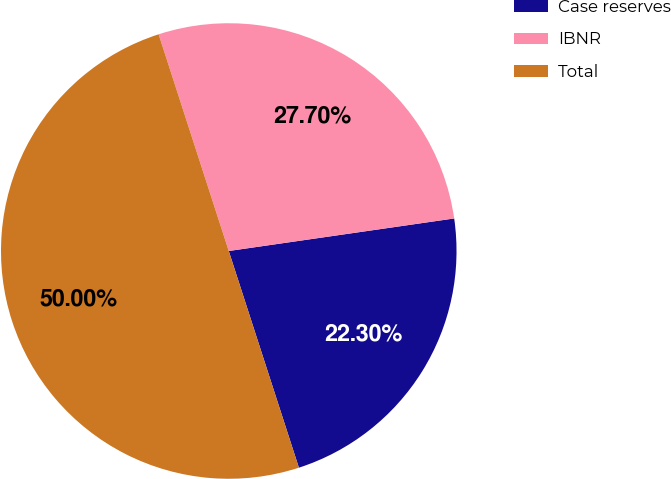Convert chart to OTSL. <chart><loc_0><loc_0><loc_500><loc_500><pie_chart><fcel>Case reserves<fcel>IBNR<fcel>Total<nl><fcel>22.3%<fcel>27.7%<fcel>50.0%<nl></chart> 